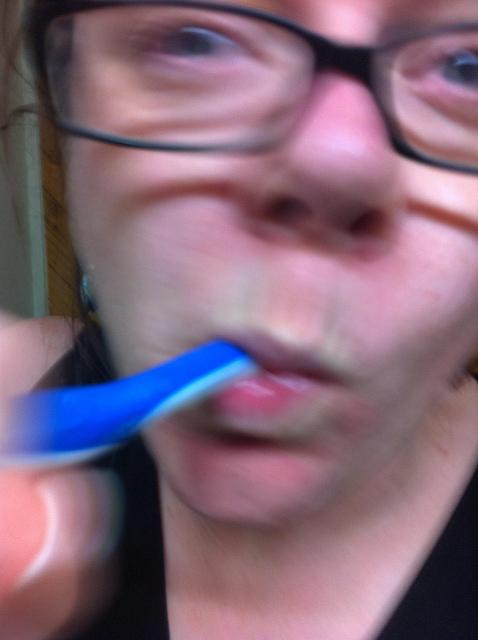Are the toothbrushes clean?
Write a very short answer. No. How many toothbrushes are pictured?
Answer briefly. 1. What race is she?
Keep it brief. White. Why is this toothbrush so short?
Keep it brief. Kid. What color is the person's eyes?
Write a very short answer. Blue. What does it look like the girl is going to do?
Keep it brief. Brush teeth. What color is the toothbrush?
Be succinct. Blue. What is resting on the person's nose?
Write a very short answer. Glasses. 